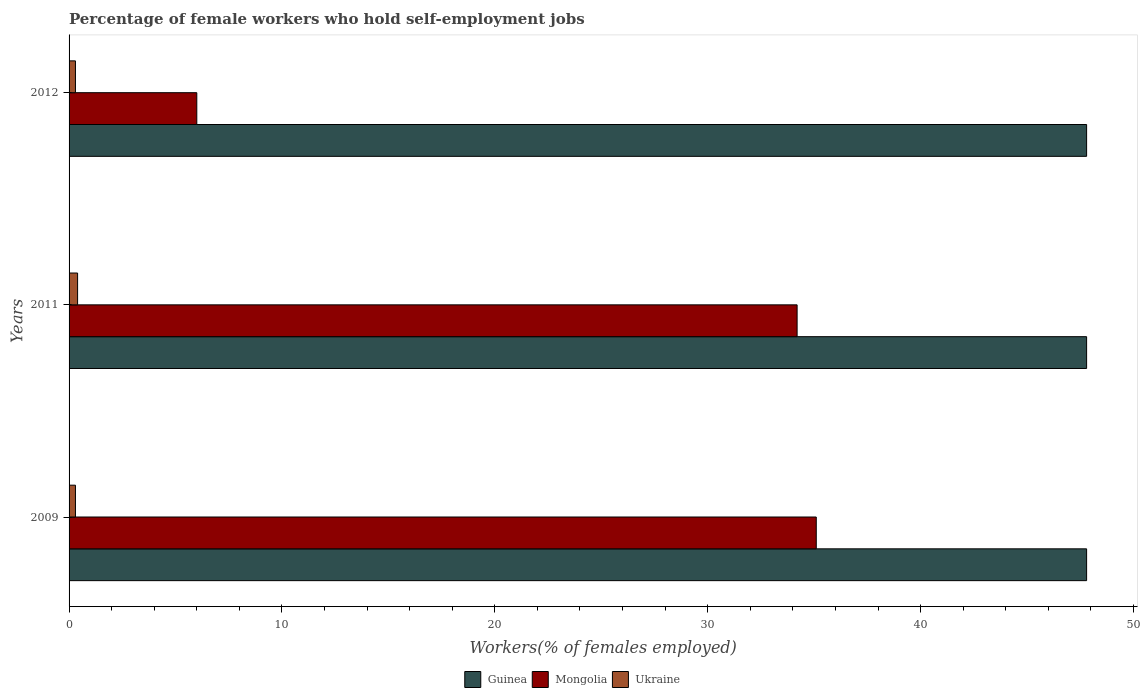How many different coloured bars are there?
Make the answer very short. 3. How many groups of bars are there?
Ensure brevity in your answer.  3. Are the number of bars on each tick of the Y-axis equal?
Your answer should be compact. Yes. How many bars are there on the 2nd tick from the top?
Your response must be concise. 3. How many bars are there on the 2nd tick from the bottom?
Provide a succinct answer. 3. What is the percentage of self-employed female workers in Ukraine in 2012?
Your response must be concise. 0.3. Across all years, what is the maximum percentage of self-employed female workers in Ukraine?
Provide a short and direct response. 0.4. Across all years, what is the minimum percentage of self-employed female workers in Mongolia?
Offer a terse response. 6. What is the total percentage of self-employed female workers in Ukraine in the graph?
Offer a terse response. 1. What is the difference between the percentage of self-employed female workers in Ukraine in 2009 and that in 2011?
Your response must be concise. -0.1. What is the difference between the percentage of self-employed female workers in Ukraine in 2011 and the percentage of self-employed female workers in Mongolia in 2012?
Ensure brevity in your answer.  -5.6. What is the average percentage of self-employed female workers in Ukraine per year?
Make the answer very short. 0.33. In the year 2011, what is the difference between the percentage of self-employed female workers in Guinea and percentage of self-employed female workers in Ukraine?
Provide a succinct answer. 47.4. What is the ratio of the percentage of self-employed female workers in Mongolia in 2011 to that in 2012?
Provide a short and direct response. 5.7. Is the difference between the percentage of self-employed female workers in Guinea in 2011 and 2012 greater than the difference between the percentage of self-employed female workers in Ukraine in 2011 and 2012?
Give a very brief answer. No. What is the difference between the highest and the second highest percentage of self-employed female workers in Mongolia?
Offer a terse response. 0.9. What is the difference between the highest and the lowest percentage of self-employed female workers in Mongolia?
Offer a very short reply. 29.1. In how many years, is the percentage of self-employed female workers in Mongolia greater than the average percentage of self-employed female workers in Mongolia taken over all years?
Provide a succinct answer. 2. What does the 1st bar from the top in 2012 represents?
Offer a very short reply. Ukraine. What does the 3rd bar from the bottom in 2011 represents?
Ensure brevity in your answer.  Ukraine. How many bars are there?
Provide a succinct answer. 9. Are all the bars in the graph horizontal?
Offer a terse response. Yes. How many years are there in the graph?
Keep it short and to the point. 3. Does the graph contain any zero values?
Your answer should be compact. No. Does the graph contain grids?
Your answer should be very brief. No. Where does the legend appear in the graph?
Ensure brevity in your answer.  Bottom center. How many legend labels are there?
Give a very brief answer. 3. What is the title of the graph?
Provide a succinct answer. Percentage of female workers who hold self-employment jobs. What is the label or title of the X-axis?
Ensure brevity in your answer.  Workers(% of females employed). What is the Workers(% of females employed) of Guinea in 2009?
Your answer should be compact. 47.8. What is the Workers(% of females employed) in Mongolia in 2009?
Provide a short and direct response. 35.1. What is the Workers(% of females employed) in Ukraine in 2009?
Offer a terse response. 0.3. What is the Workers(% of females employed) in Guinea in 2011?
Your response must be concise. 47.8. What is the Workers(% of females employed) in Mongolia in 2011?
Your answer should be very brief. 34.2. What is the Workers(% of females employed) of Ukraine in 2011?
Give a very brief answer. 0.4. What is the Workers(% of females employed) in Guinea in 2012?
Provide a succinct answer. 47.8. What is the Workers(% of females employed) in Mongolia in 2012?
Offer a very short reply. 6. What is the Workers(% of females employed) in Ukraine in 2012?
Keep it short and to the point. 0.3. Across all years, what is the maximum Workers(% of females employed) in Guinea?
Give a very brief answer. 47.8. Across all years, what is the maximum Workers(% of females employed) of Mongolia?
Your answer should be compact. 35.1. Across all years, what is the maximum Workers(% of females employed) of Ukraine?
Keep it short and to the point. 0.4. Across all years, what is the minimum Workers(% of females employed) of Guinea?
Make the answer very short. 47.8. Across all years, what is the minimum Workers(% of females employed) in Ukraine?
Your response must be concise. 0.3. What is the total Workers(% of females employed) in Guinea in the graph?
Ensure brevity in your answer.  143.4. What is the total Workers(% of females employed) of Mongolia in the graph?
Your response must be concise. 75.3. What is the total Workers(% of females employed) of Ukraine in the graph?
Make the answer very short. 1. What is the difference between the Workers(% of females employed) in Mongolia in 2009 and that in 2011?
Your answer should be compact. 0.9. What is the difference between the Workers(% of females employed) of Mongolia in 2009 and that in 2012?
Your response must be concise. 29.1. What is the difference between the Workers(% of females employed) in Ukraine in 2009 and that in 2012?
Offer a terse response. 0. What is the difference between the Workers(% of females employed) of Guinea in 2011 and that in 2012?
Provide a succinct answer. 0. What is the difference between the Workers(% of females employed) in Mongolia in 2011 and that in 2012?
Ensure brevity in your answer.  28.2. What is the difference between the Workers(% of females employed) of Guinea in 2009 and the Workers(% of females employed) of Mongolia in 2011?
Ensure brevity in your answer.  13.6. What is the difference between the Workers(% of females employed) of Guinea in 2009 and the Workers(% of females employed) of Ukraine in 2011?
Your answer should be very brief. 47.4. What is the difference between the Workers(% of females employed) of Mongolia in 2009 and the Workers(% of females employed) of Ukraine in 2011?
Give a very brief answer. 34.7. What is the difference between the Workers(% of females employed) in Guinea in 2009 and the Workers(% of females employed) in Mongolia in 2012?
Offer a very short reply. 41.8. What is the difference between the Workers(% of females employed) of Guinea in 2009 and the Workers(% of females employed) of Ukraine in 2012?
Your answer should be compact. 47.5. What is the difference between the Workers(% of females employed) in Mongolia in 2009 and the Workers(% of females employed) in Ukraine in 2012?
Make the answer very short. 34.8. What is the difference between the Workers(% of females employed) in Guinea in 2011 and the Workers(% of females employed) in Mongolia in 2012?
Your answer should be compact. 41.8. What is the difference between the Workers(% of females employed) of Guinea in 2011 and the Workers(% of females employed) of Ukraine in 2012?
Provide a short and direct response. 47.5. What is the difference between the Workers(% of females employed) in Mongolia in 2011 and the Workers(% of females employed) in Ukraine in 2012?
Give a very brief answer. 33.9. What is the average Workers(% of females employed) of Guinea per year?
Provide a succinct answer. 47.8. What is the average Workers(% of females employed) in Mongolia per year?
Your answer should be compact. 25.1. What is the average Workers(% of females employed) of Ukraine per year?
Provide a succinct answer. 0.33. In the year 2009, what is the difference between the Workers(% of females employed) of Guinea and Workers(% of females employed) of Ukraine?
Ensure brevity in your answer.  47.5. In the year 2009, what is the difference between the Workers(% of females employed) of Mongolia and Workers(% of females employed) of Ukraine?
Offer a terse response. 34.8. In the year 2011, what is the difference between the Workers(% of females employed) in Guinea and Workers(% of females employed) in Ukraine?
Keep it short and to the point. 47.4. In the year 2011, what is the difference between the Workers(% of females employed) in Mongolia and Workers(% of females employed) in Ukraine?
Your response must be concise. 33.8. In the year 2012, what is the difference between the Workers(% of females employed) of Guinea and Workers(% of females employed) of Mongolia?
Your answer should be compact. 41.8. In the year 2012, what is the difference between the Workers(% of females employed) in Guinea and Workers(% of females employed) in Ukraine?
Offer a terse response. 47.5. What is the ratio of the Workers(% of females employed) of Mongolia in 2009 to that in 2011?
Offer a terse response. 1.03. What is the ratio of the Workers(% of females employed) of Ukraine in 2009 to that in 2011?
Ensure brevity in your answer.  0.75. What is the ratio of the Workers(% of females employed) of Mongolia in 2009 to that in 2012?
Make the answer very short. 5.85. What is the ratio of the Workers(% of females employed) in Ukraine in 2009 to that in 2012?
Make the answer very short. 1. What is the difference between the highest and the second highest Workers(% of females employed) of Ukraine?
Make the answer very short. 0.1. What is the difference between the highest and the lowest Workers(% of females employed) in Guinea?
Keep it short and to the point. 0. What is the difference between the highest and the lowest Workers(% of females employed) of Mongolia?
Your answer should be very brief. 29.1. What is the difference between the highest and the lowest Workers(% of females employed) in Ukraine?
Make the answer very short. 0.1. 